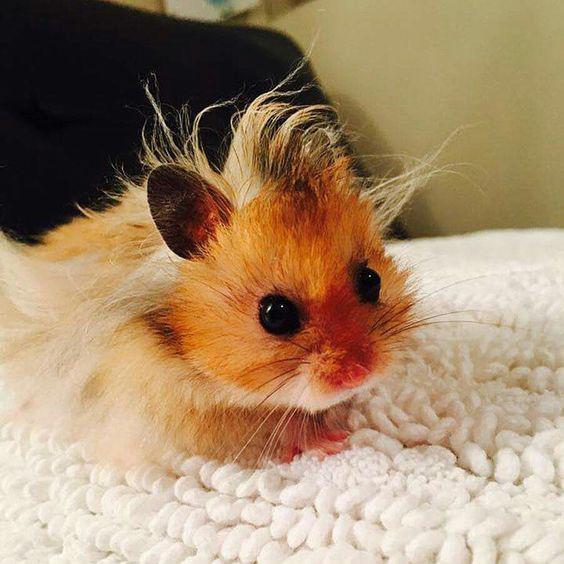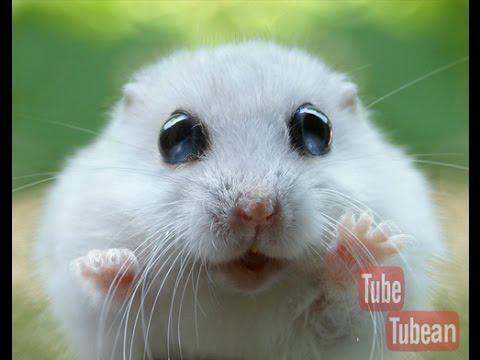The first image is the image on the left, the second image is the image on the right. Evaluate the accuracy of this statement regarding the images: "There are exactly two animals.". Is it true? Answer yes or no. Yes. 